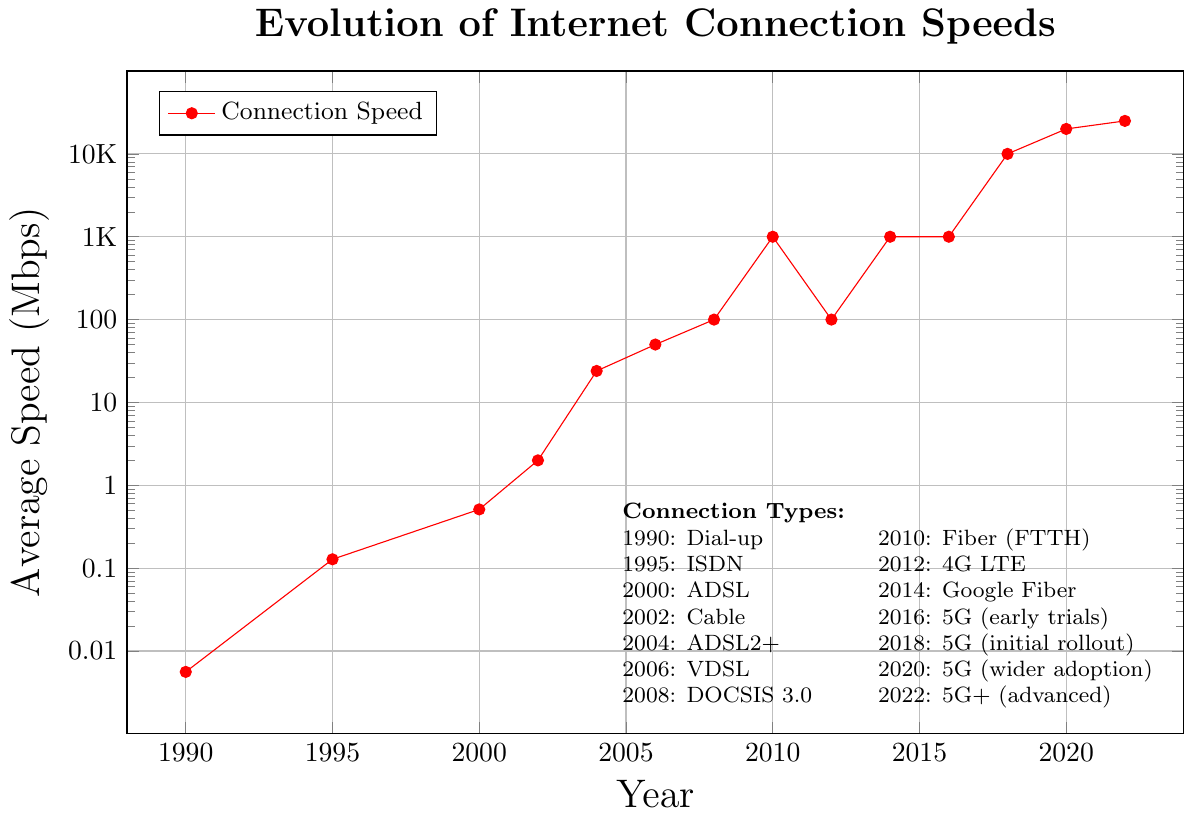What was the average internet speed in 2002? Locate the year 2002 on the x-axis and find the corresponding data point on the y-axis, which is labeled with the average speed.
Answer: 2 Mbps Which year saw the introduction of internet speeds of 1000 Mbps? Find the data points labeled with 1000 Mbps on the y-axis and trace horizontally to the years on the x-axis.
Answer: 2010, 2014, 2016 How does the average speed in 2008 compare to that in 2012? Locate 2008 and 2012 on the x-axis and read the corresponding y-values. Compare 100 Mbps (2008) and 100 Mbps (2012).
Answer: Equal What is the approximate increase in average speed from 1990 to 2000? Find the speeds for the years 1990 and 2000 on the y-axis. Subtract the speed in 1990 (0.0056 Mbps) from the speed in 2000 (0.512 Mbps).
Answer: 0.5064 Mbps By how much did the internet speed increase between 2018 and 2022? Subtract the average speed in 2018 (10000 Mbps) from the average speed in 2022 (25000 Mbps).
Answer: 15000 Mbps Which connection type was introduced in 2004, and what was its average speed? Look for the year 2004 on the x-axis and correlate it to the label in the legend or the data point.
Answer: ADSL2+, 24 Mbps Between which consecutive years did the average speed see the highest increase? Calculate the differences between consecutive years and find the largest difference. For instance, compare the increase from 2010 (1000 Mbps) to 2018 (10000 Mbps). The increase is 9000 Mbps from 2016 to 2018.
Answer: 2018 to 2020 What visual pattern do you observe about the trend in internet speeds over time? From the earliest point to the latest, observe the overall direction of the data points in the plot. The speed increases exponentially after the transition from dial-up to newer technologies.
Answer: Exponential increase 